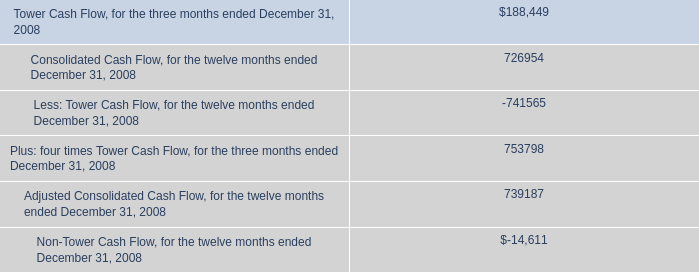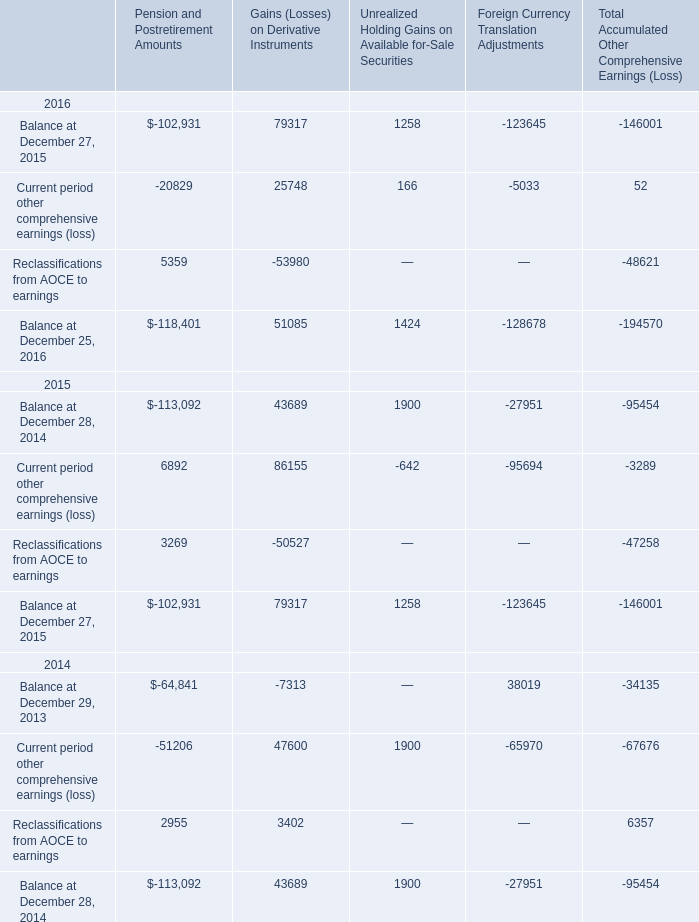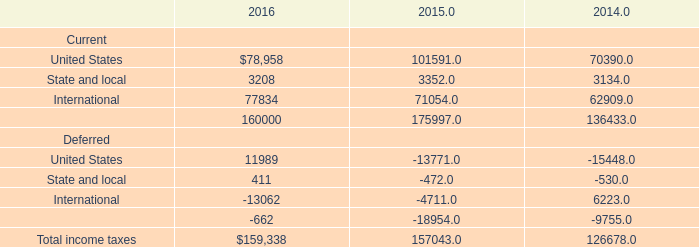What is the total amount of Balance at December 27, 2015 of Pension and Postretirement Amounts, International Deferred of 2016, and Reclassifications from AOCE to earnings 2014 of Pension and Postretirement Amounts ? 
Computations: ((102931.0 + 13062.0) + 2955.0)
Answer: 118948.0. 